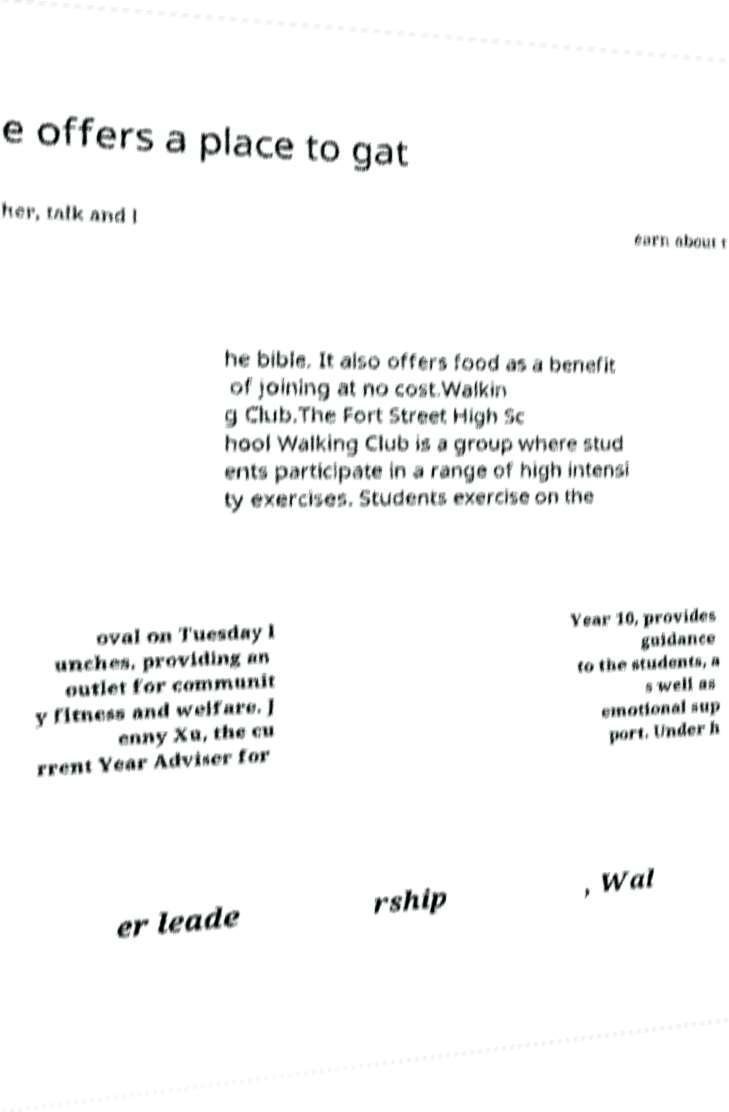Can you accurately transcribe the text from the provided image for me? e offers a place to gat her, talk and l earn about t he bible. It also offers food as a benefit of joining at no cost.Walkin g Club.The Fort Street High Sc hool Walking Club is a group where stud ents participate in a range of high intensi ty exercises. Students exercise on the oval on Tuesday l unches, providing an outlet for communit y fitness and welfare. J enny Xu, the cu rrent Year Adviser for Year 10, provides guidance to the students, a s well as emotional sup port. Under h er leade rship , Wal 